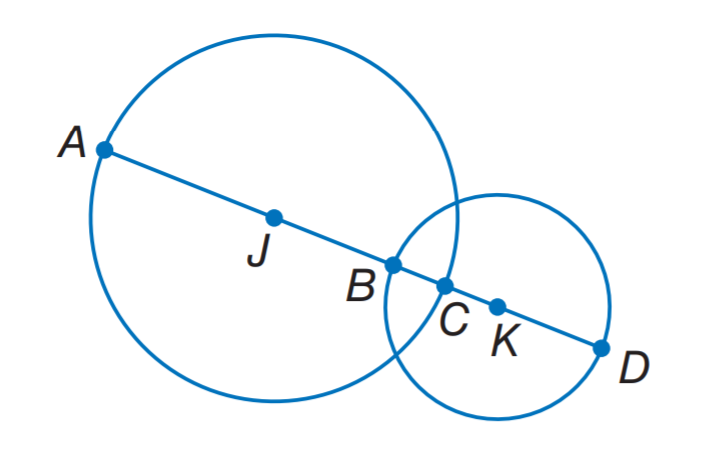Answer the mathemtical geometry problem and directly provide the correct option letter.
Question: Circle J has a radius of 10 units, \odot K has a radius of 8 units, and B C = 5.4 units. Find A B.
Choices: A: 12.6 B: 14.6 C: 20.6 D: 30.6 B 